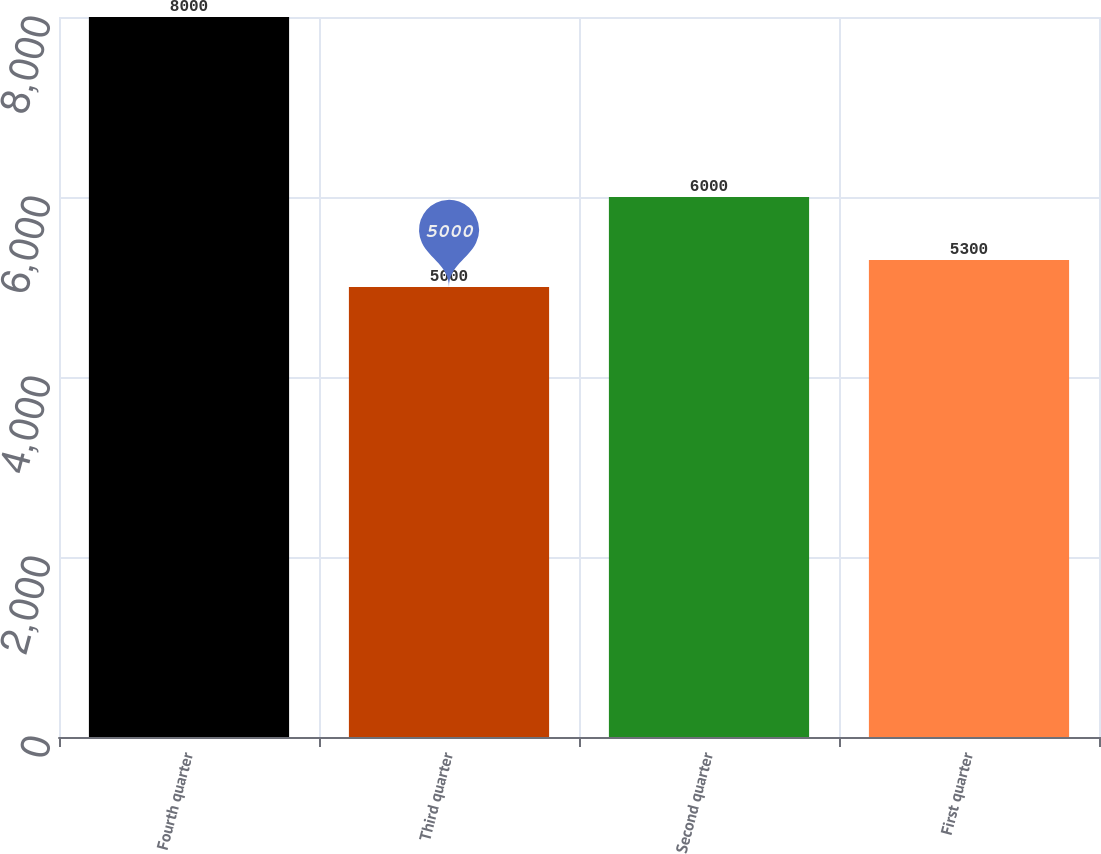Convert chart. <chart><loc_0><loc_0><loc_500><loc_500><bar_chart><fcel>Fourth quarter<fcel>Third quarter<fcel>Second quarter<fcel>First quarter<nl><fcel>8000<fcel>5000<fcel>6000<fcel>5300<nl></chart> 